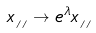<formula> <loc_0><loc_0><loc_500><loc_500>x _ { { \, _ { / \, / } } } \rightarrow e ^ { \lambda } x _ { { \, _ { / \, / } } }</formula> 